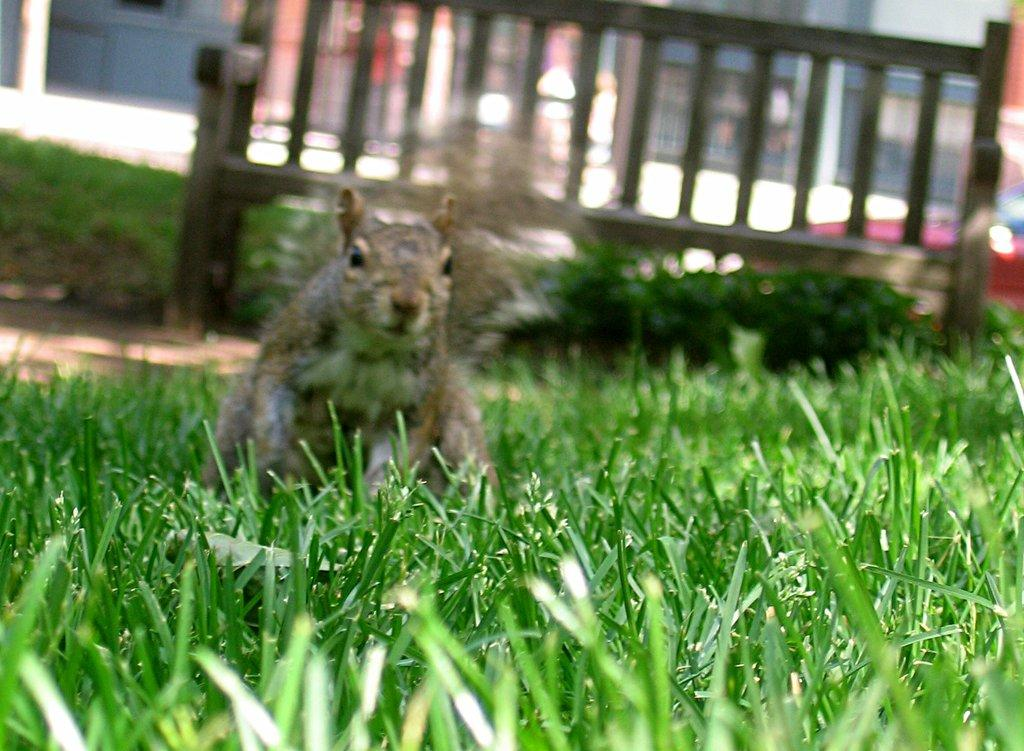What type of vegetation is present in the image? There is grass in the image. Is there any living creature visible on the grass? Yes, there is an animal on the grass. What type of seating is present in the image? There is a bench in the image. Where is the basin located in the image? There is no basin present in the image. What type of plantation can be seen in the background of the image? There is no plantation visible in the image; it only features grass, an animal, and a bench. 